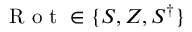Convert formula to latex. <formula><loc_0><loc_0><loc_500><loc_500>R o t \in \{ S , Z , S ^ { \dagger } \}</formula> 